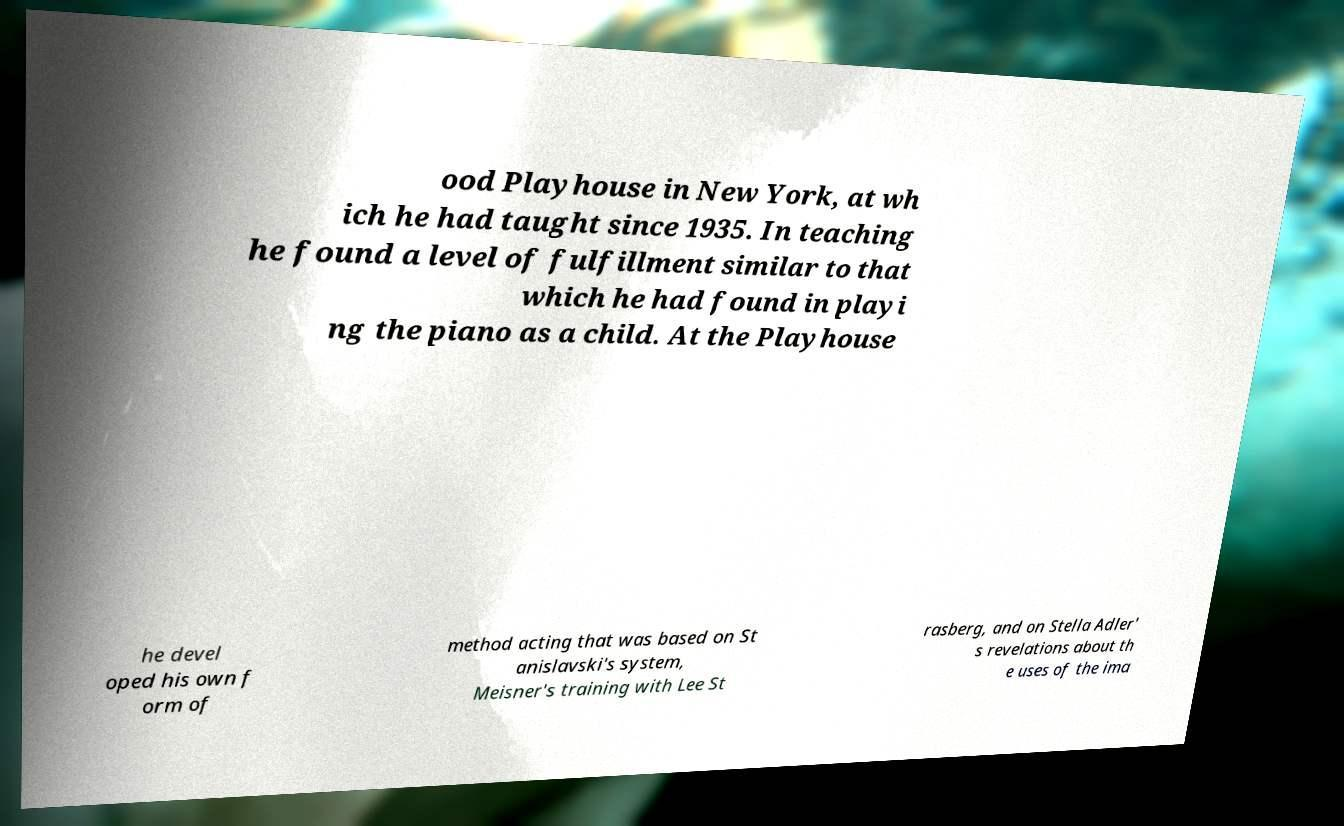For documentation purposes, I need the text within this image transcribed. Could you provide that? ood Playhouse in New York, at wh ich he had taught since 1935. In teaching he found a level of fulfillment similar to that which he had found in playi ng the piano as a child. At the Playhouse he devel oped his own f orm of method acting that was based on St anislavski's system, Meisner's training with Lee St rasberg, and on Stella Adler' s revelations about th e uses of the ima 